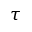<formula> <loc_0><loc_0><loc_500><loc_500>\tau</formula> 